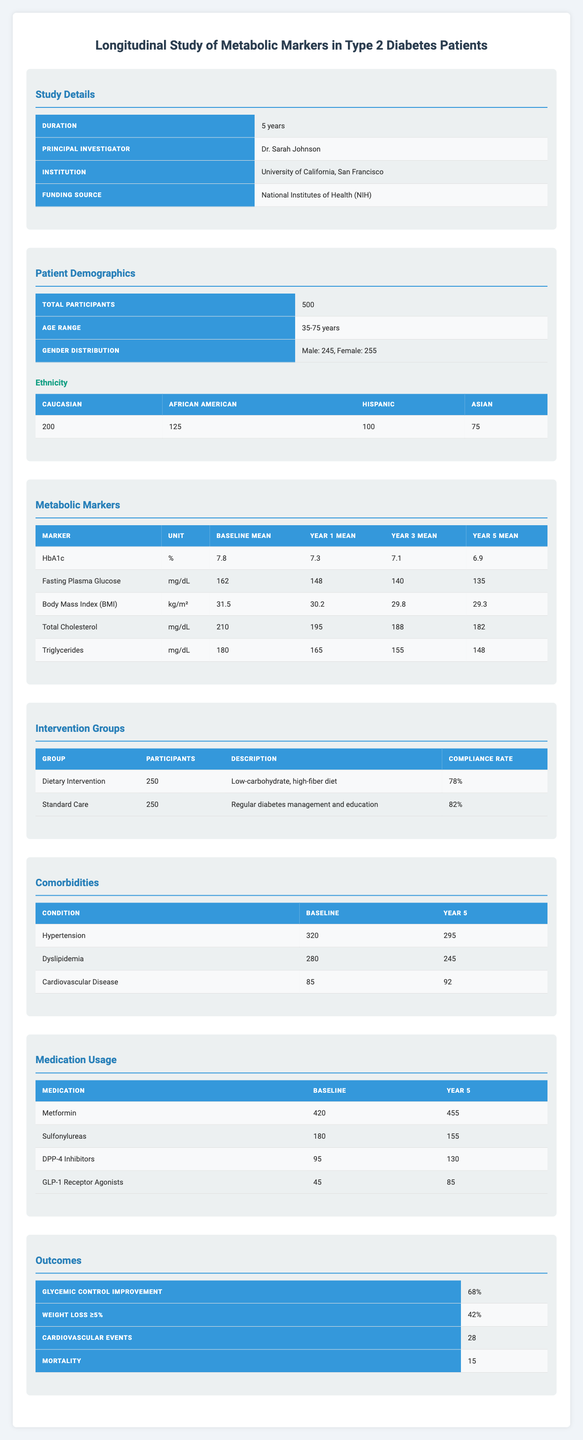What is the title of the study? The study title is provided in the "Study Details" section of the table. It is stated clearly as "Longitudinal Study of Metabolic Markers in Type 2 Diabetes Patients."
Answer: Longitudinal Study of Metabolic Markers in Type 2 Diabetes Patients How many total participants were involved in the study? The "Patient Demographics" section indicates the total number of participants, which is listed as 500.
Answer: 500 What was the mean Fasting Plasma Glucose level at Year 1? In the "Metabolic Markers" section, the mean values for Fasting Plasma Glucose are displayed, with Year 1 listed as 148 mg/dL.
Answer: 148 mg/dL Which intervention group had a higher compliance rate? Comparing the compliance rates in the "Intervention Groups" section, the Standard Care group is listed with a compliance rate of 82%, while the Dietary Intervention group has 78%. Therefore, Standard Care has a higher compliance rate.
Answer: Standard Care What was the change in mean HbA1c from Baseline to Year 5? The Baseline mean HbA1c is 7.8%, and the Year 5 mean is 6.9%. To find the change, subtract Year 5 from Baseline: 7.8 - 6.9 = 0.9%.
Answer: 0.9% Did the number of participants using Metformin increase over the study period? The "Medication Usage" section shows that the number of participants using Metformin increased from 420 at Baseline to 455 at Year 5, which indicates a yes.
Answer: Yes What is the percentage of participants who achieved Glycemic Control Improvement? The "Outcomes" section clearly states that 68% of participants achieved improvement in glycemic control.
Answer: 68% How many participants were in the Dietary Intervention group, and what was its compliance rate? The "Intervention Groups" section provides data; there are 250 participants in the Dietary Intervention group, and the compliance rate is 78%.
Answer: 250 participants, 78% compliance What was the overall change in Hypertension from Baseline to Year 5? From the "Comorbidities" section, the number of participants with Hypertension decreased from 320 at Baseline to 295 at Year 5. To find the change, perform the subtraction: 320 - 295 = 25.
Answer: 25 What is the average mean change for all metabolic markers from Baseline to Year 5? To calculate the average mean change, first find the change for each marker (e.g., HbA1c: 7.8 - 6.9 = 0.9, Fasting Plasma Glucose: 162 - 135 = 27, etc.) and then average the values. Summing these changes gives 0.9 + 27 + 2.2 + 28 + 32 = 90.3. There are 5 markers, so the average change is 90.3 / 5 = 18.06.
Answer: 18.06 Is there an increase in the number of patients diagnosed with Cardiovascular Disease over the five years? The "Comorbidities" section provides the figure for Cardiovascular Disease, showing an increase from 85 at Baseline to 92 at Year 5, confirming an increase.
Answer: Yes 